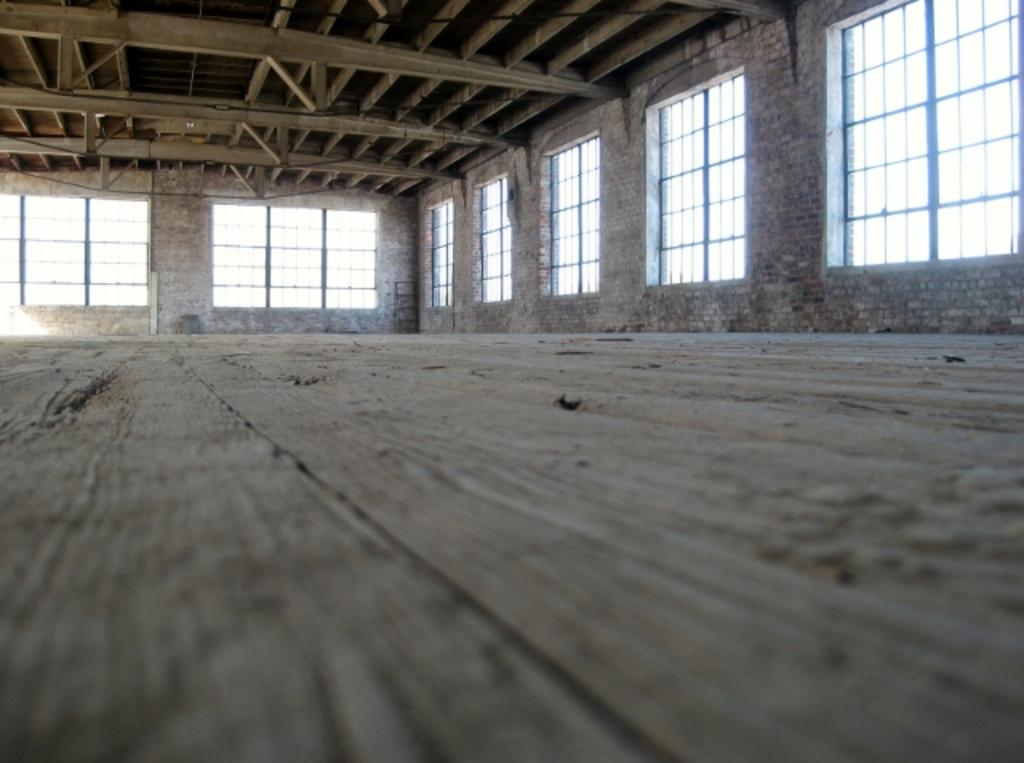Where was the image taken? The image was taken inside a room. What can be seen through the windows in the room? The windows in the room allow us to see outside. What is the current state of the building where the room is located? The room appears to be part of an under-construction building. What is the purpose of the cent in the image? There is no cent present in the image. Is there a fight happening in the image? There is no fight depicted in the image. 